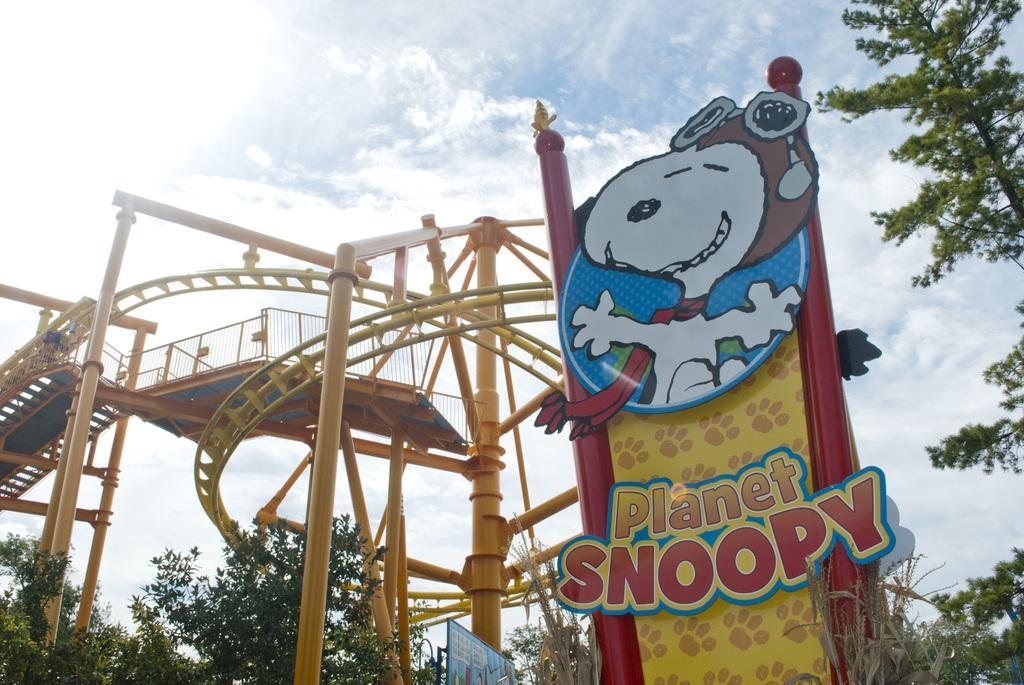What is the condition of the sky in the image? The sky is cloudy in the image. What type of vegetation can be seen in the image? There are trees in the image. What structure is present in the image? There is a hoarding in the image. What type of barrier is visible in the image? There is a fence in the image. What long, thin objects can be seen in the image? There are rods in the image. What type of linen is draped over the trees in the image? There is no linen draped over the trees in the image. What riddle can be solved by looking at the image? There is no riddle associated with the image. 